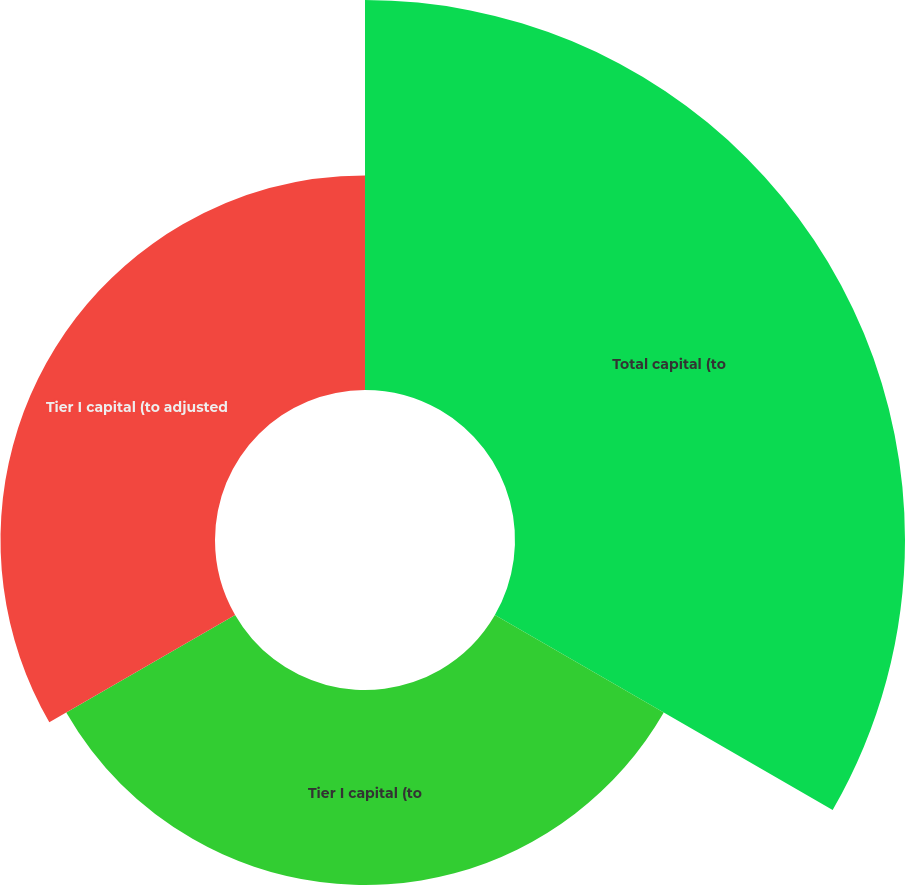<chart> <loc_0><loc_0><loc_500><loc_500><pie_chart><fcel>Total capital (to<fcel>Tier I capital (to<fcel>Tier I capital (to adjusted<nl><fcel>48.78%<fcel>24.39%<fcel>26.83%<nl></chart> 